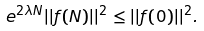Convert formula to latex. <formula><loc_0><loc_0><loc_500><loc_500>e ^ { 2 \lambda N } | | f ( N ) | | ^ { 2 } \leq | | f ( 0 ) | | ^ { 2 } .</formula> 